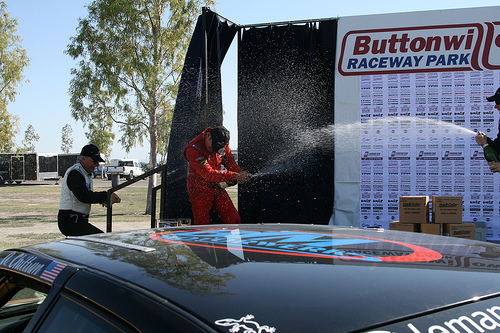<image>
Is the champagne on the man? Yes. Looking at the image, I can see the champagne is positioned on top of the man, with the man providing support. Is the pickup truck on the man? No. The pickup truck is not positioned on the man. They may be near each other, but the pickup truck is not supported by or resting on top of the man. 